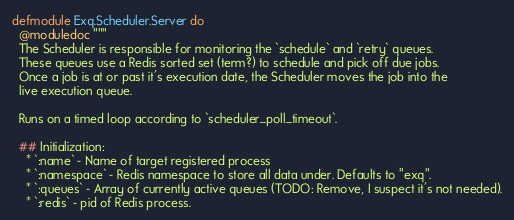<code> <loc_0><loc_0><loc_500><loc_500><_Elixir_>defmodule Exq.Scheduler.Server do
  @moduledoc """
  The Scheduler is responsible for monitoring the `schedule` and `retry` queues.
  These queues use a Redis sorted set (term?) to schedule and pick off due jobs.
  Once a job is at or past it's execution date, the Scheduler moves the job into the
  live execution queue.

  Runs on a timed loop according to `scheduler_poll_timeout`.

  ## Initialization:
    * `:name` - Name of target registered process
    * `:namespace` - Redis namespace to store all data under. Defaults to "exq".
    * `:queues` - Array of currently active queues (TODO: Remove, I suspect it's not needed).
    * `:redis` - pid of Redis process.</code> 